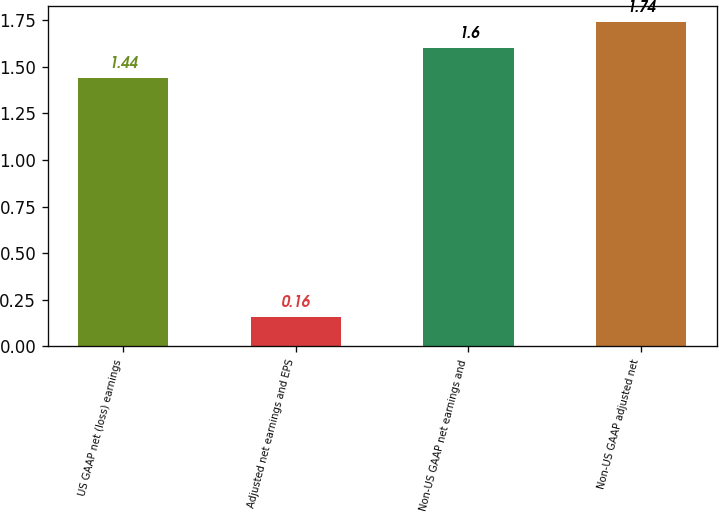<chart> <loc_0><loc_0><loc_500><loc_500><bar_chart><fcel>US GAAP net (loss) earnings<fcel>Adjusted net earnings and EPS<fcel>Non-US GAAP net earnings and<fcel>Non-US GAAP adjusted net<nl><fcel>1.44<fcel>0.16<fcel>1.6<fcel>1.74<nl></chart> 